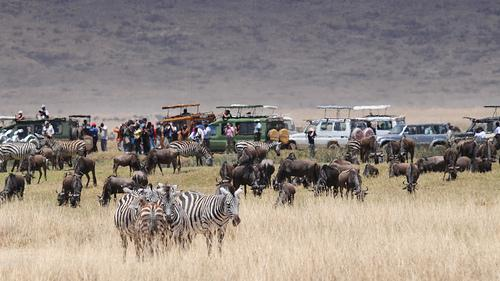Question: what color is the field?
Choices:
A. Green.
B. Beige.
C. Brown.
D. Yellow.
Answer with the letter. Answer: B Question: where are the zebras?
Choices:
A. In the zoo.
B. Africa.
C. In the field.
D. Farm.
Answer with the letter. Answer: C Question: what are the people riding in?
Choices:
A. Cars.
B. Jeeps.
C. Buses.
D. Planes.
Answer with the letter. Answer: B Question: how many zebras are there?
Choices:
A. Two.
B. Four.
C. Three.
D. Five.
Answer with the letter. Answer: C Question: what kind of animals are these?
Choices:
A. Elephants.
B. Giraffes.
C. Dogs.
D. Zebras.
Answer with the letter. Answer: D 